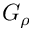<formula> <loc_0><loc_0><loc_500><loc_500>G _ { \rho }</formula> 